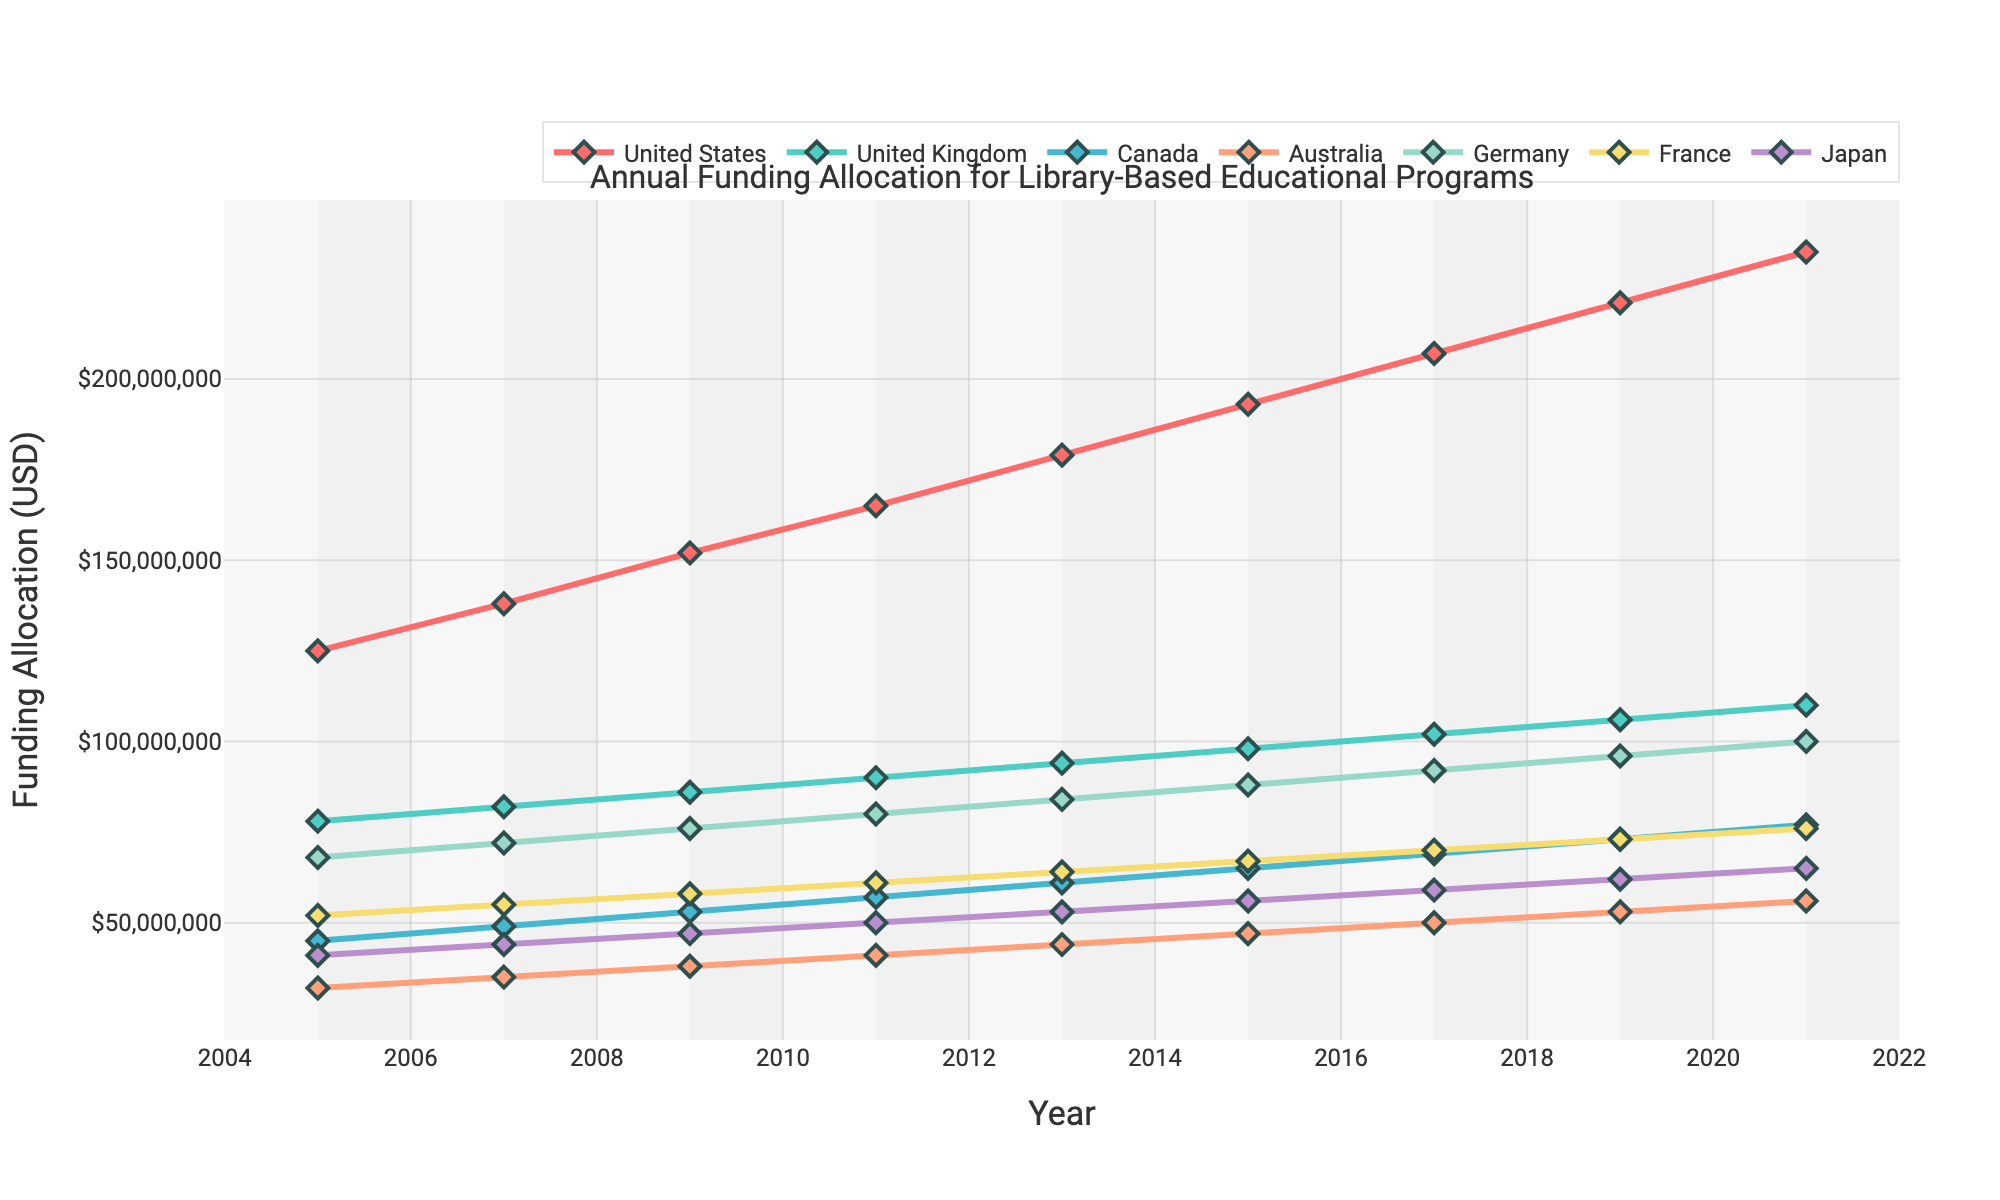What is the overall trend in funding allocation for library-based educational programs in the United States from 2005 to 2021? The plot shows an upward trend in the funding allocation for library-based educational programs in the United States, increasing steadily year by year from 125 million USD in 2005 to 235 million USD in 2021.
Answer: Upward trend Which country had the lowest funding allocation in 2005, and what was the amount? According to the plot, Australia had the lowest funding allocation in 2005, with an amount of 32 million USD.
Answer: Australia, 32 million USD Between 2009 and 2013, how much did Canada’s funding allocation for library-based educational programs increase by? In 2009, Canada's funding allocation was 53 million USD, and by 2013, it had increased to 61 million USD. Therefore, the increase is 61 million USD - 53 million USD = 8 million USD.
Answer: 8 million USD Compare the 2021 funding allocations for Germany and France. Which country allocated more, and by how much? In 2021, Germany allocated 100 million USD, and France allocated 76 million USD. Germany allocated 24 million USD more than France (100 million USD - 76 million USD).
Answer: Germany, 24 million USD What is the average annual funding allocation for Japan from 2005 to 2021? The funding allocations for Japan from 2005 to 2021 are (41 + 44 + 47 + 50 + 53 + 56 + 59 + 62 + 65) million USD. Sum these values: 477 million USD. There are 9 years, so the average is 477 million USD / 9 = 53 million USD.
Answer: 53 million USD Which country showed the most consistent increase in funding allocation from 2005 to 2021, and how can you tell? The United States showed the most consistent increase, as the plot for the United States shows a steady and linear increase without any dips or fluctuations.
Answer: United States Calculate the total funding allocation for library-based educational programs across all countries in 2015. Adding the allocations: United States (193 million USD) + United Kingdom (98 million USD) + Canada (65 million USD) + Australia (47 million USD) + Germany (88 million USD) + France (67 million USD) + Japan (56 million USD) = 614 million USD.
Answer: 614 million USD 